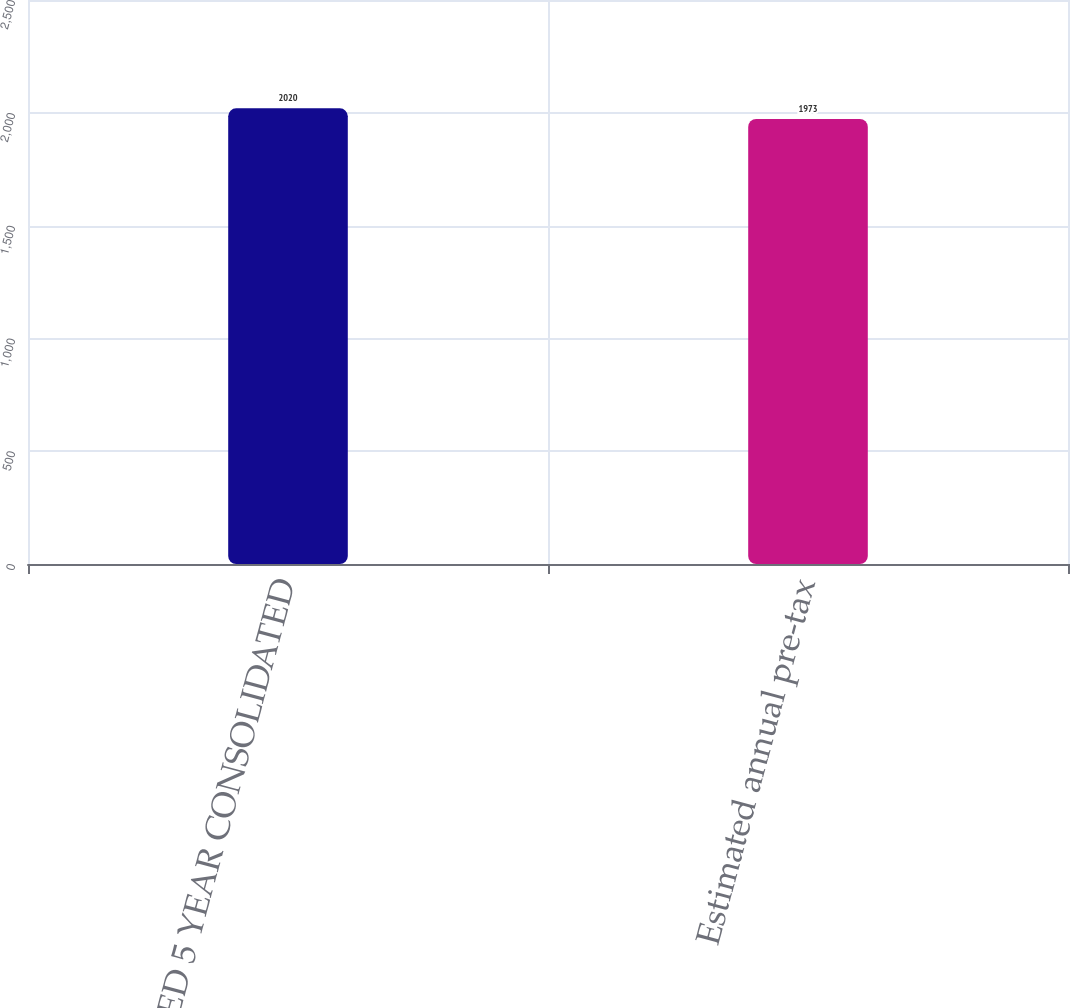Convert chart. <chart><loc_0><loc_0><loc_500><loc_500><bar_chart><fcel>ESTIMATED 5 YEAR CONSOLIDATED<fcel>Estimated annual pre-tax<nl><fcel>2020<fcel>1973<nl></chart> 